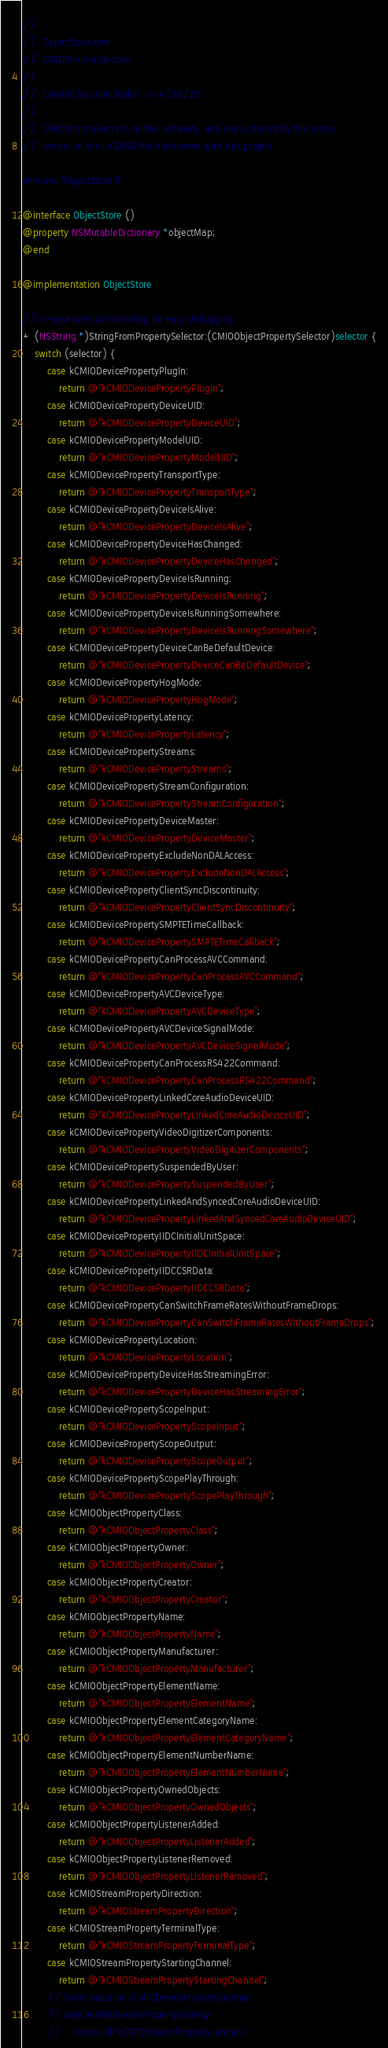Convert code to text. <code><loc_0><loc_0><loc_500><loc_500><_ObjectiveC_>//
//  ObjectStore.mm
//  CMIOMinimalSample
//
//  Created by John Boiles  on 4/10/20.
//
//  CMIOMinimalSample is free software, and use is bound by the terms
//  set out in the LICENSE file distributed with this project.

#import "ObjectStore.h"

@interface ObjectStore ()
@property NSMutableDictionary *objectMap;
@end

@implementation ObjectStore

// 4-byte selectors to string for easy debugging
+ (NSString *)StringFromPropertySelector:(CMIOObjectPropertySelector)selector {
    switch (selector) {
        case kCMIODevicePropertyPlugIn:
            return @"kCMIODevicePropertyPlugIn";
        case kCMIODevicePropertyDeviceUID:
            return @"kCMIODevicePropertyDeviceUID";
        case kCMIODevicePropertyModelUID:
            return @"kCMIODevicePropertyModelUID";
        case kCMIODevicePropertyTransportType:
            return @"kCMIODevicePropertyTransportType";
        case kCMIODevicePropertyDeviceIsAlive:
            return @"kCMIODevicePropertyDeviceIsAlive";
        case kCMIODevicePropertyDeviceHasChanged:
            return @"kCMIODevicePropertyDeviceHasChanged";
        case kCMIODevicePropertyDeviceIsRunning:
            return @"kCMIODevicePropertyDeviceIsRunning";
        case kCMIODevicePropertyDeviceIsRunningSomewhere:
            return @"kCMIODevicePropertyDeviceIsRunningSomewhere";
        case kCMIODevicePropertyDeviceCanBeDefaultDevice:
            return @"kCMIODevicePropertyDeviceCanBeDefaultDevice";
        case kCMIODevicePropertyHogMode:
            return @"kCMIODevicePropertyHogMode";
        case kCMIODevicePropertyLatency:
            return @"kCMIODevicePropertyLatency";
        case kCMIODevicePropertyStreams:
            return @"kCMIODevicePropertyStreams";
        case kCMIODevicePropertyStreamConfiguration:
            return @"kCMIODevicePropertyStreamConfiguration";
        case kCMIODevicePropertyDeviceMaster:
            return @"kCMIODevicePropertyDeviceMaster";
        case kCMIODevicePropertyExcludeNonDALAccess:
            return @"kCMIODevicePropertyExcludeNonDALAccess";
        case kCMIODevicePropertyClientSyncDiscontinuity:
            return @"kCMIODevicePropertyClientSyncDiscontinuity";
        case kCMIODevicePropertySMPTETimeCallback:
            return @"kCMIODevicePropertySMPTETimeCallback";
        case kCMIODevicePropertyCanProcessAVCCommand:
            return @"kCMIODevicePropertyCanProcessAVCCommand";
        case kCMIODevicePropertyAVCDeviceType:
            return @"kCMIODevicePropertyAVCDeviceType";
        case kCMIODevicePropertyAVCDeviceSignalMode:
            return @"kCMIODevicePropertyAVCDeviceSignalMode";
        case kCMIODevicePropertyCanProcessRS422Command:
            return @"kCMIODevicePropertyCanProcessRS422Command";
        case kCMIODevicePropertyLinkedCoreAudioDeviceUID:
            return @"kCMIODevicePropertyLinkedCoreAudioDeviceUID";
        case kCMIODevicePropertyVideoDigitizerComponents:
            return @"kCMIODevicePropertyVideoDigitizerComponents";
        case kCMIODevicePropertySuspendedByUser:
            return @"kCMIODevicePropertySuspendedByUser";
        case kCMIODevicePropertyLinkedAndSyncedCoreAudioDeviceUID:
            return @"kCMIODevicePropertyLinkedAndSyncedCoreAudioDeviceUID";
        case kCMIODevicePropertyIIDCInitialUnitSpace:
            return @"kCMIODevicePropertyIIDCInitialUnitSpace";
        case kCMIODevicePropertyIIDCCSRData:
            return @"kCMIODevicePropertyIIDCCSRData";
        case kCMIODevicePropertyCanSwitchFrameRatesWithoutFrameDrops:
            return @"kCMIODevicePropertyCanSwitchFrameRatesWithoutFrameDrops";
        case kCMIODevicePropertyLocation:
            return @"kCMIODevicePropertyLocation";
        case kCMIODevicePropertyDeviceHasStreamingError:
            return @"kCMIODevicePropertyDeviceHasStreamingError";
        case kCMIODevicePropertyScopeInput:
            return @"kCMIODevicePropertyScopeInput";
        case kCMIODevicePropertyScopeOutput:
            return @"kCMIODevicePropertyScopeOutput";
        case kCMIODevicePropertyScopePlayThrough:
            return @"kCMIODevicePropertyScopePlayThrough";
        case kCMIOObjectPropertyClass:
            return @"kCMIOObjectPropertyClass";
        case kCMIOObjectPropertyOwner:
            return @"kCMIOObjectPropertyOwner";
        case kCMIOObjectPropertyCreator:
            return @"kCMIOObjectPropertyCreator";
        case kCMIOObjectPropertyName:
            return @"kCMIOObjectPropertyName";
        case kCMIOObjectPropertyManufacturer:
            return @"kCMIOObjectPropertyManufacturer";
        case kCMIOObjectPropertyElementName:
            return @"kCMIOObjectPropertyElementName";
        case kCMIOObjectPropertyElementCategoryName:
            return @"kCMIOObjectPropertyElementCategoryName";
        case kCMIOObjectPropertyElementNumberName:
            return @"kCMIOObjectPropertyElementNumberName";
        case kCMIOObjectPropertyOwnedObjects:
            return @"kCMIOObjectPropertyOwnedObjects";
        case kCMIOObjectPropertyListenerAdded:
            return @"kCMIOObjectPropertyListenerAdded";
        case kCMIOObjectPropertyListenerRemoved:
            return @"kCMIOObjectPropertyListenerRemoved";
        case kCMIOStreamPropertyDirection:
            return @"kCMIOStreamPropertyDirection";
        case kCMIOStreamPropertyTerminalType:
            return @"kCMIOStreamPropertyTerminalType";
        case kCMIOStreamPropertyStartingChannel:
            return @"kCMIOStreamPropertyStartingChannel";
        // Same value as kCMIODevicePropertyLatency
        // case kCMIOStreamPropertyLatency:
        //     return @"kCMIOStreamPropertyLatency";</code> 